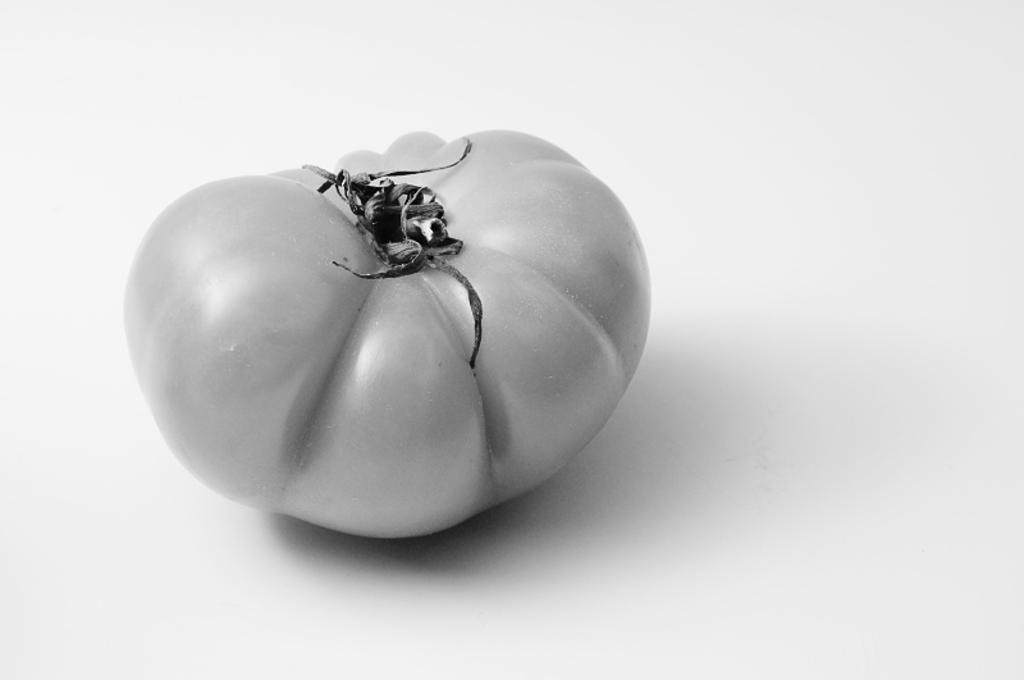What is the main subject of the image? The main subject of the image is a tomato. Does the tomato have any specific features in the image? Yes, the tomato has a shadow in the image. What is the color of the surface on which the tomato and its shadow are placed? The tomato and its shadow are on a white surface. What is the color of the background in the image? The background of the image is white. What type of scarf is draped over the tomato in the image? There is no scarf present in the image; it features a tomato and its shadow on a white surface. Can you tell me how many cows are visible in the image? There are no cows visible in the image; it features a tomato and its shadow on a white surface. 